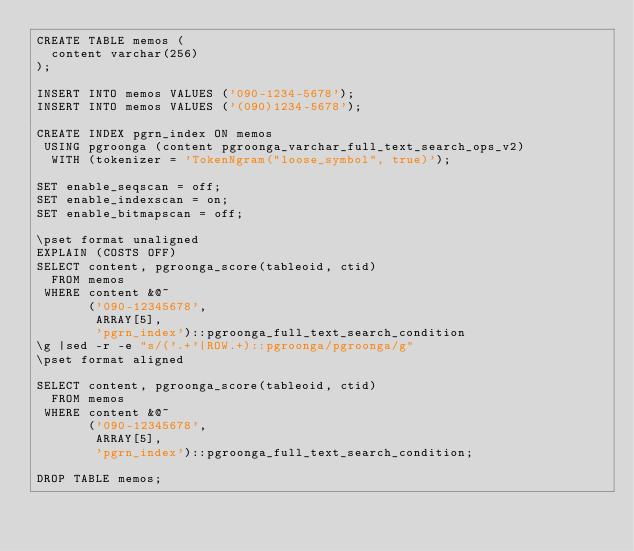<code> <loc_0><loc_0><loc_500><loc_500><_SQL_>CREATE TABLE memos (
  content varchar(256)
);

INSERT INTO memos VALUES ('090-1234-5678');
INSERT INTO memos VALUES ('(090)1234-5678');

CREATE INDEX pgrn_index ON memos
 USING pgroonga (content pgroonga_varchar_full_text_search_ops_v2)
  WITH (tokenizer = 'TokenNgram("loose_symbol", true)');

SET enable_seqscan = off;
SET enable_indexscan = on;
SET enable_bitmapscan = off;

\pset format unaligned
EXPLAIN (COSTS OFF)
SELECT content, pgroonga_score(tableoid, ctid)
  FROM memos
 WHERE content &@~
       ('090-12345678',
        ARRAY[5],
        'pgrn_index')::pgroonga_full_text_search_condition
\g |sed -r -e "s/('.+'|ROW.+)::pgroonga/pgroonga/g"
\pset format aligned

SELECT content, pgroonga_score(tableoid, ctid)
  FROM memos
 WHERE content &@~
       ('090-12345678',
        ARRAY[5],
        'pgrn_index')::pgroonga_full_text_search_condition;

DROP TABLE memos;
</code> 